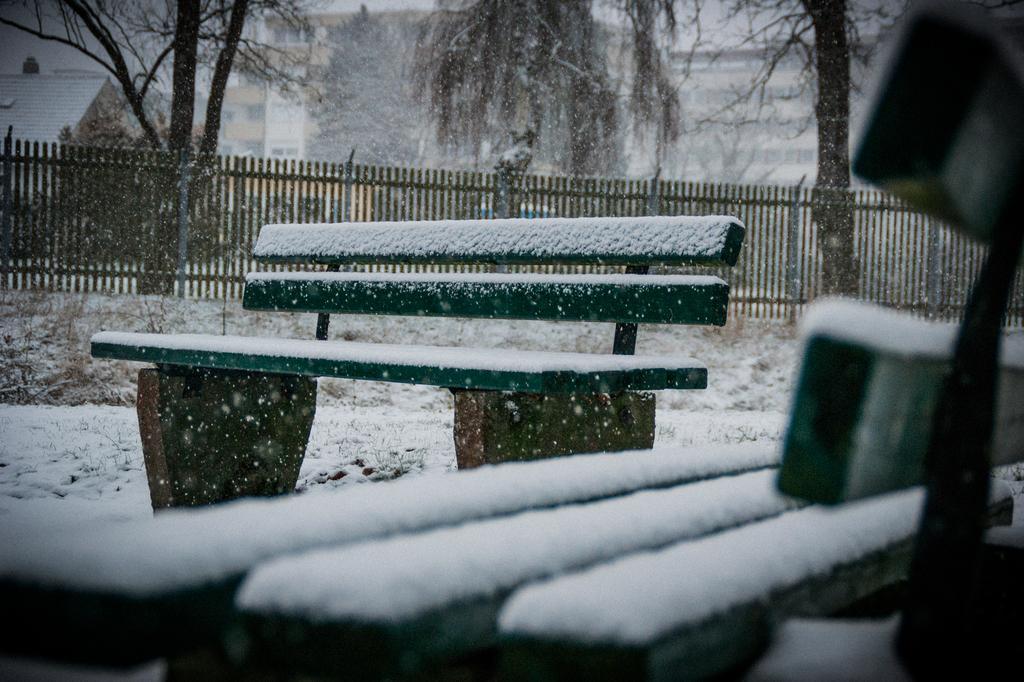Describe this image in one or two sentences. In this image in front there are benches. At the bottom of the image there is snow on the surface. In the background of the image there is a metal fence. There are trees, buildings. 